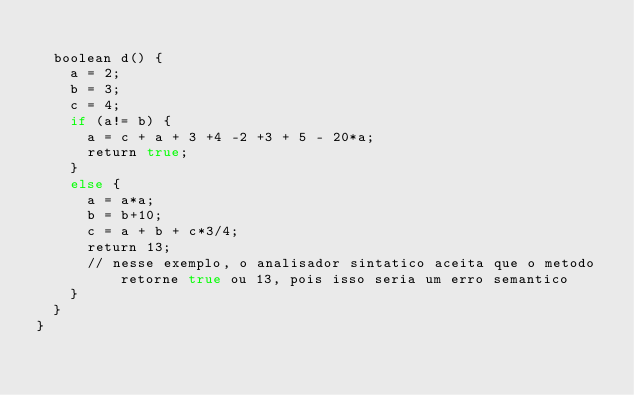<code> <loc_0><loc_0><loc_500><loc_500><_SML_>	
	boolean d() {
		a = 2;
		b = 3;
		c = 4;
		if (a!= b) {
			a = c + a + 3 +4 -2 +3 + 5 - 20*a;
			return true;
		}
		else {
			a = a*a;
			b = b+10;
			c = a + b + c*3/4;
			return 13;
			// nesse exemplo, o analisador sintatico aceita que o metodo retorne true ou 13, pois isso seria um erro semantico
		}
	}
}</code> 